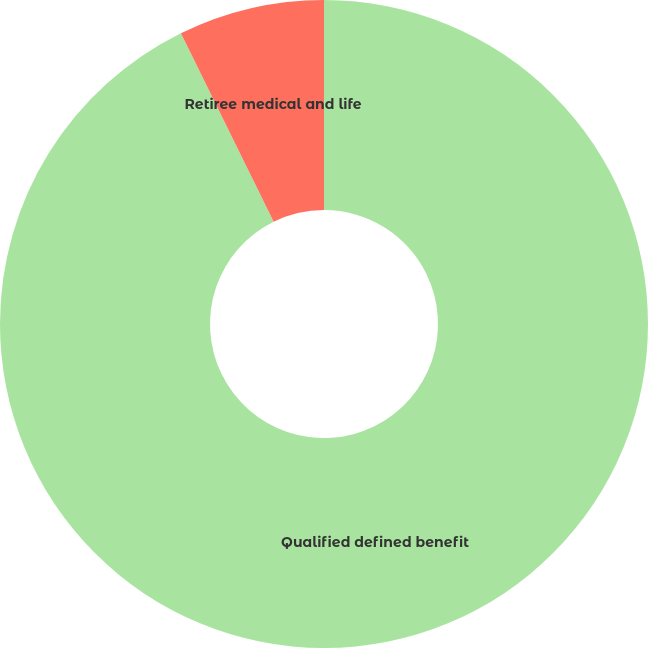Convert chart. <chart><loc_0><loc_0><loc_500><loc_500><pie_chart><fcel>Qualified defined benefit<fcel>Retiree medical and life<nl><fcel>92.72%<fcel>7.28%<nl></chart> 